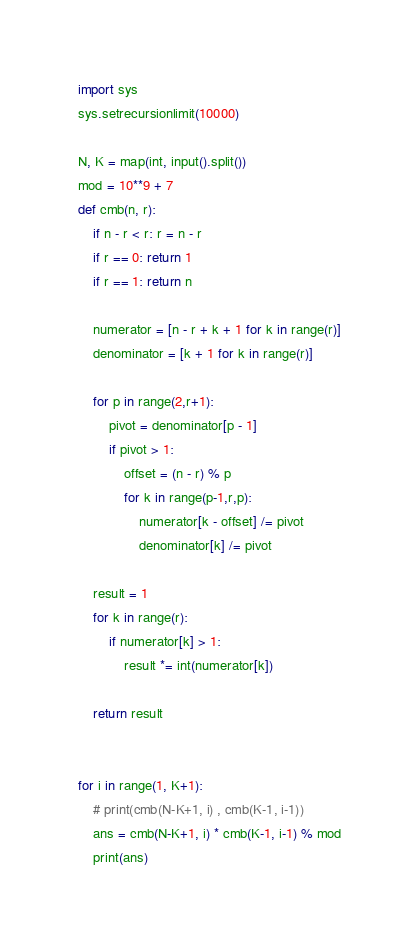<code> <loc_0><loc_0><loc_500><loc_500><_Python_>import sys
sys.setrecursionlimit(10000)

N, K = map(int, input().split())
mod = 10**9 + 7
def cmb(n, r):
    if n - r < r: r = n - r
    if r == 0: return 1
    if r == 1: return n

    numerator = [n - r + k + 1 for k in range(r)]
    denominator = [k + 1 for k in range(r)]

    for p in range(2,r+1):
        pivot = denominator[p - 1]
        if pivot > 1:
            offset = (n - r) % p
            for k in range(p-1,r,p):
                numerator[k - offset] /= pivot
                denominator[k] /= pivot

    result = 1
    for k in range(r):
        if numerator[k] > 1:
            result *= int(numerator[k])

    return result


for i in range(1, K+1):
    # print(cmb(N-K+1, i) , cmb(K-1, i-1))
    ans = cmb(N-K+1, i) * cmb(K-1, i-1) % mod
    print(ans)

</code> 